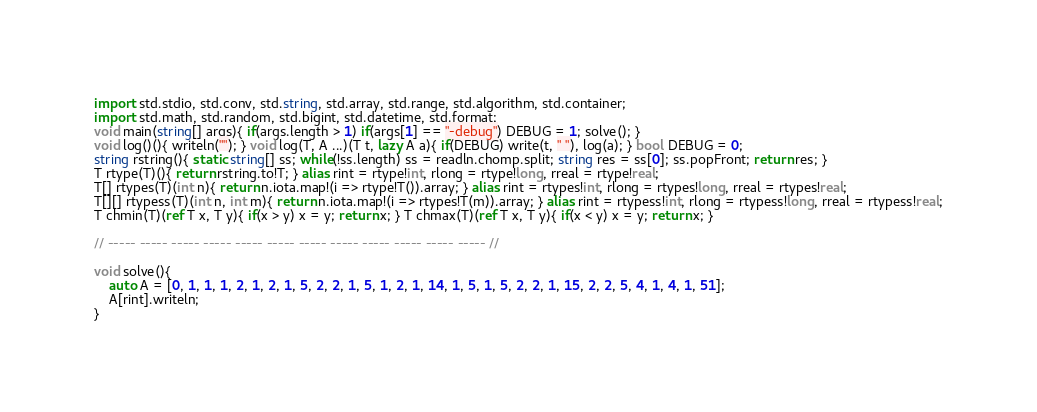Convert code to text. <code><loc_0><loc_0><loc_500><loc_500><_D_>import std.stdio, std.conv, std.string, std.array, std.range, std.algorithm, std.container;
import std.math, std.random, std.bigint, std.datetime, std.format;
void main(string[] args){ if(args.length > 1) if(args[1] == "-debug") DEBUG = 1; solve(); }
void log()(){ writeln(""); } void log(T, A ...)(T t, lazy A a){ if(DEBUG) write(t, " "), log(a); } bool DEBUG = 0; 
string rstring(){ static string[] ss; while(!ss.length) ss = readln.chomp.split; string res = ss[0]; ss.popFront; return res; }
T rtype(T)(){ return rstring.to!T; } alias rint = rtype!int, rlong = rtype!long, rreal = rtype!real;
T[] rtypes(T)(int n){ return n.iota.map!(i => rtype!T()).array; } alias rint = rtypes!int, rlong = rtypes!long, rreal = rtypes!real;
T[][] rtypess(T)(int n, int m){ return n.iota.map!(i => rtypes!T(m)).array; } alias rint = rtypess!int, rlong = rtypess!long, rreal = rtypess!real;
T chmin(T)(ref T x, T y){ if(x > y) x = y; return x; } T chmax(T)(ref T x, T y){ if(x < y) x = y; return x; }

// ----- ----- ----- ----- ----- ----- ----- ----- ----- ----- ----- ----- //

void solve(){
	auto A = [0, 1, 1, 1, 2, 1, 2, 1, 5, 2, 2, 1, 5, 1, 2, 1, 14, 1, 5, 1, 5, 2, 2, 1, 15, 2, 2, 5, 4, 1, 4, 1, 51];
	A[rint].writeln;
}
</code> 